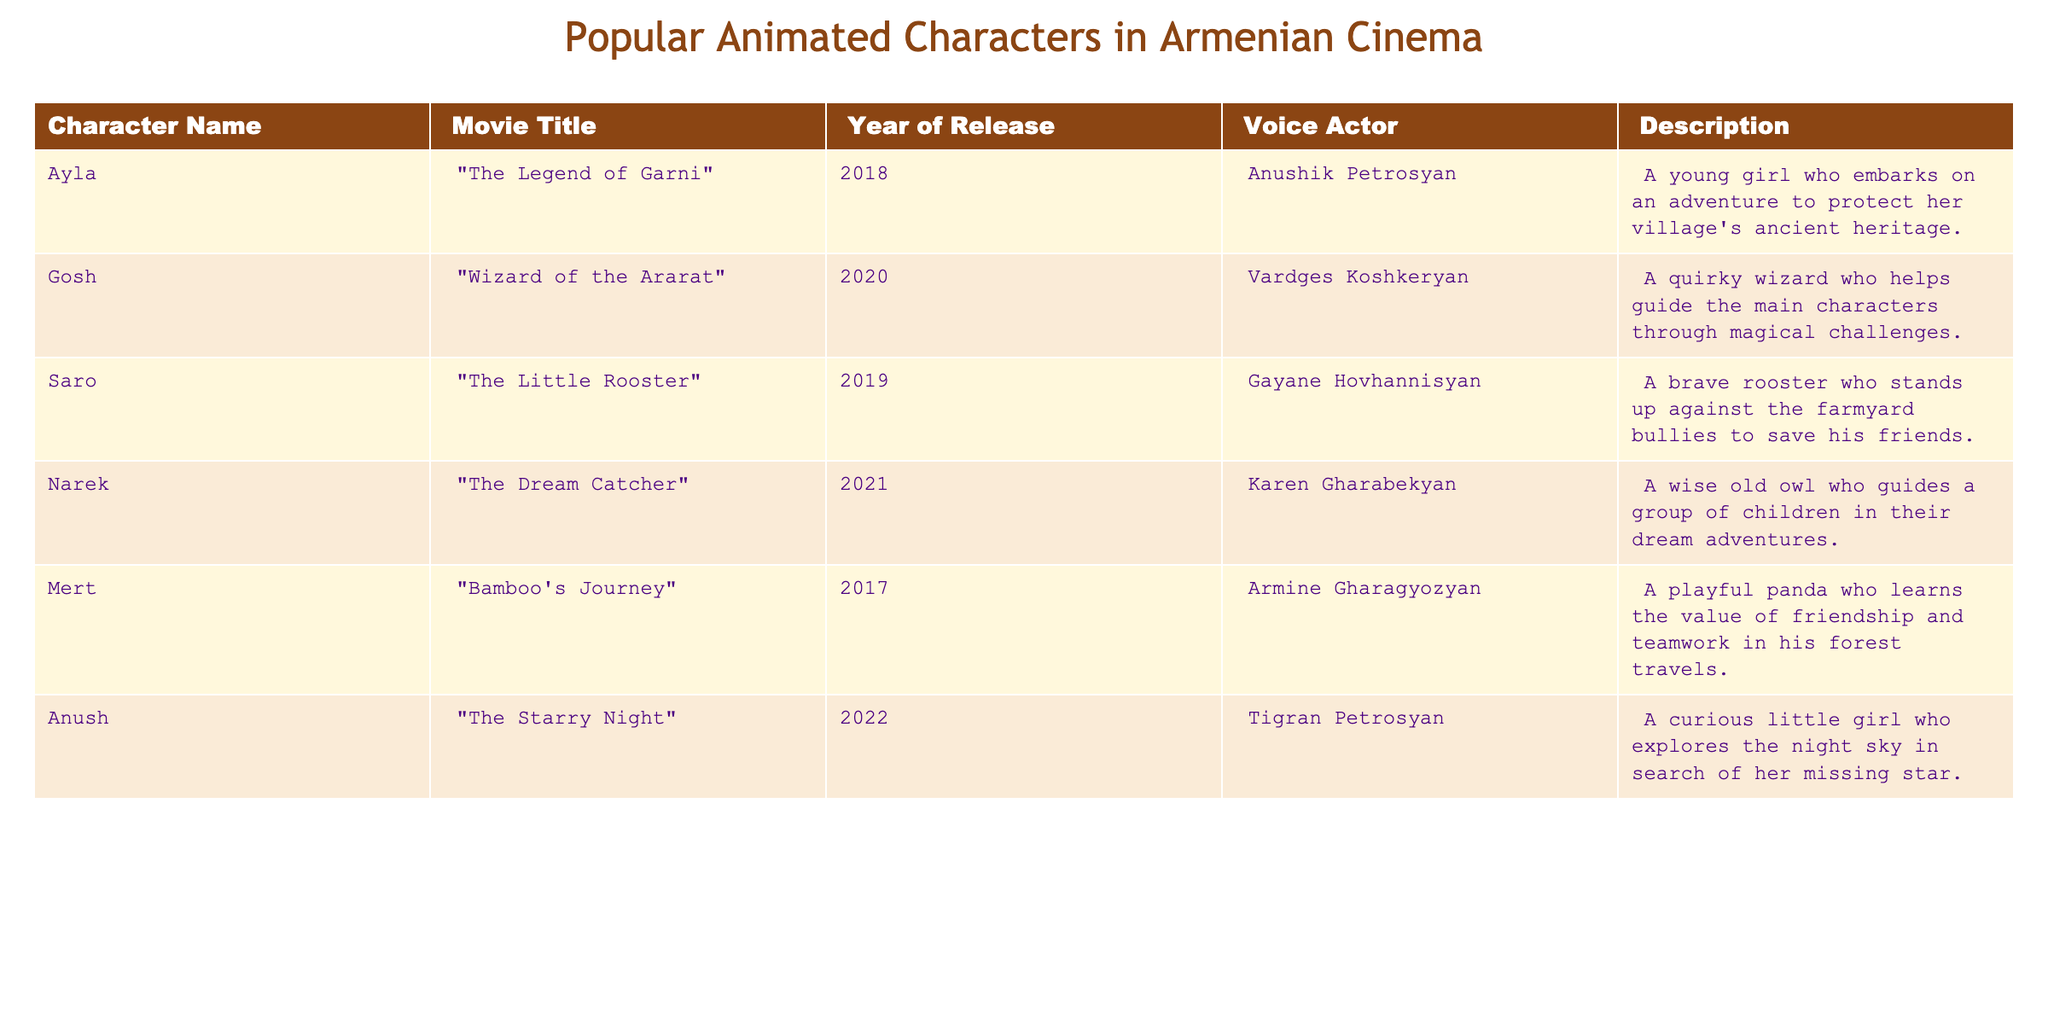What is the title of the movie featuring the character Ayla? The table lists Ayla under the column "Character Name" along with the corresponding "Movie Title," which is "The Legend of Garni."
Answer: The Legend of Garni Which character is voiced by Anushik Petrosyan? Referring to the "Voice Actor" column in the table, Anushik Petrosyan voices the character Ayla.
Answer: Ayla Is there a character named Gosh in the table? The character Gosh is listed in the table under "Character Name," confirming that there is indeed a character by that name.
Answer: Yes In which year was "The Little Rooster" released? By checking the "Movie Title" column for "The Little Rooster," we find the corresponding "Year of Release" listed as 2019.
Answer: 2019 How many characters were released after 2019? By reviewing the "Year of Release" column, I can identify characters from the movies: "The Dream Catcher" (2021) and "The Starry Night" (2022), making a total of 2 characters after 2019.
Answer: 2 Which character appears in the movie "Bamboo's Journey"? The "Movie Title" column indicates that the character associated with "Bamboo's Journey" is Mert, confirming that Mert is the character in that movie.
Answer: Mert What is the average year of release for the movies featuring these animated characters? To calculate the average, sum the years of release: (2018 + 2020 + 2019 + 2021 + 2017 + 2022) = 2017. The number of movies is 6, so the average year is 2017/6 ≈ 2019.5. Rounding this gives us 2020.
Answer: 2020 Which animated character is described as a "curious little girl"? Looking at the "Description" column, Anush from the movie "The Starry Night" is described as a "curious little girl," directly answering the question.
Answer: Anush Was "Wizard of the Ararat" released before or after 2020? The "Year of Release" for "Wizard of the Ararat" is listed as 2020, indicating that it was released in that exact year. Thus, it was not before 2020.
Answer: Neither (it was released in 2020) 